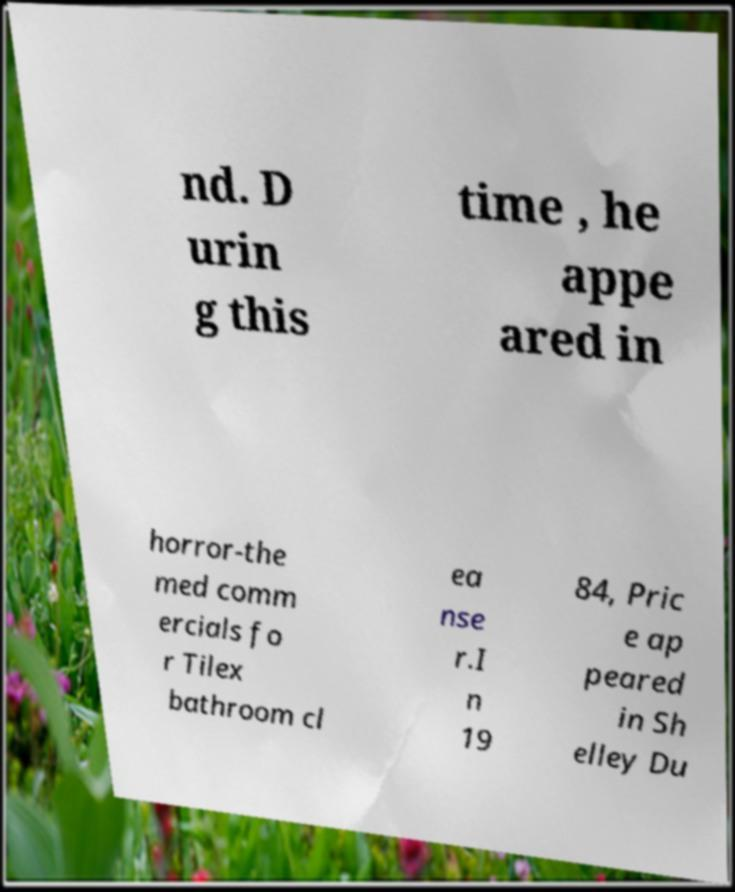Can you read and provide the text displayed in the image?This photo seems to have some interesting text. Can you extract and type it out for me? nd. D urin g this time , he appe ared in horror-the med comm ercials fo r Tilex bathroom cl ea nse r.I n 19 84, Pric e ap peared in Sh elley Du 